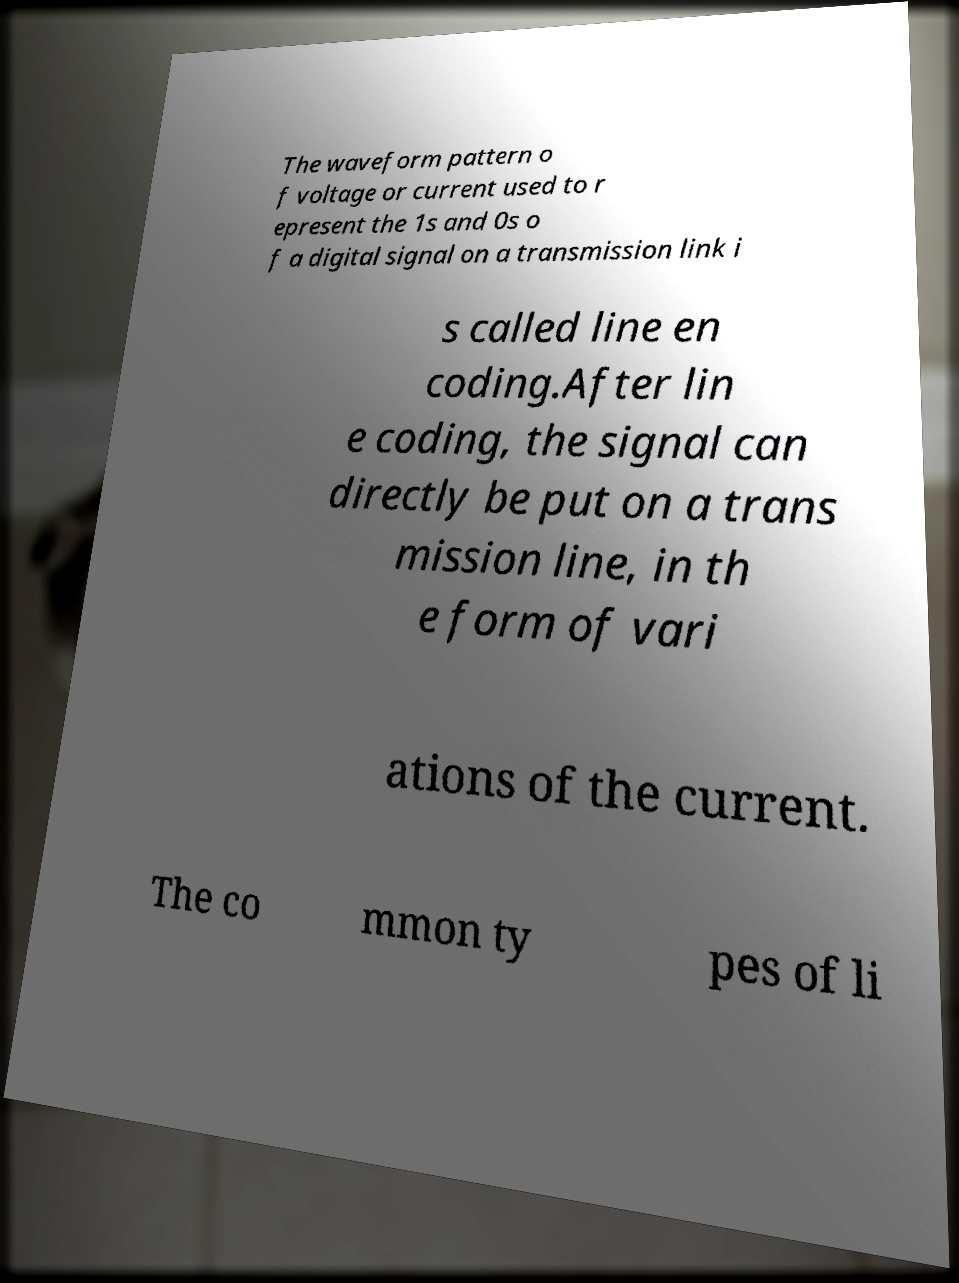Can you accurately transcribe the text from the provided image for me? The waveform pattern o f voltage or current used to r epresent the 1s and 0s o f a digital signal on a transmission link i s called line en coding.After lin e coding, the signal can directly be put on a trans mission line, in th e form of vari ations of the current. The co mmon ty pes of li 